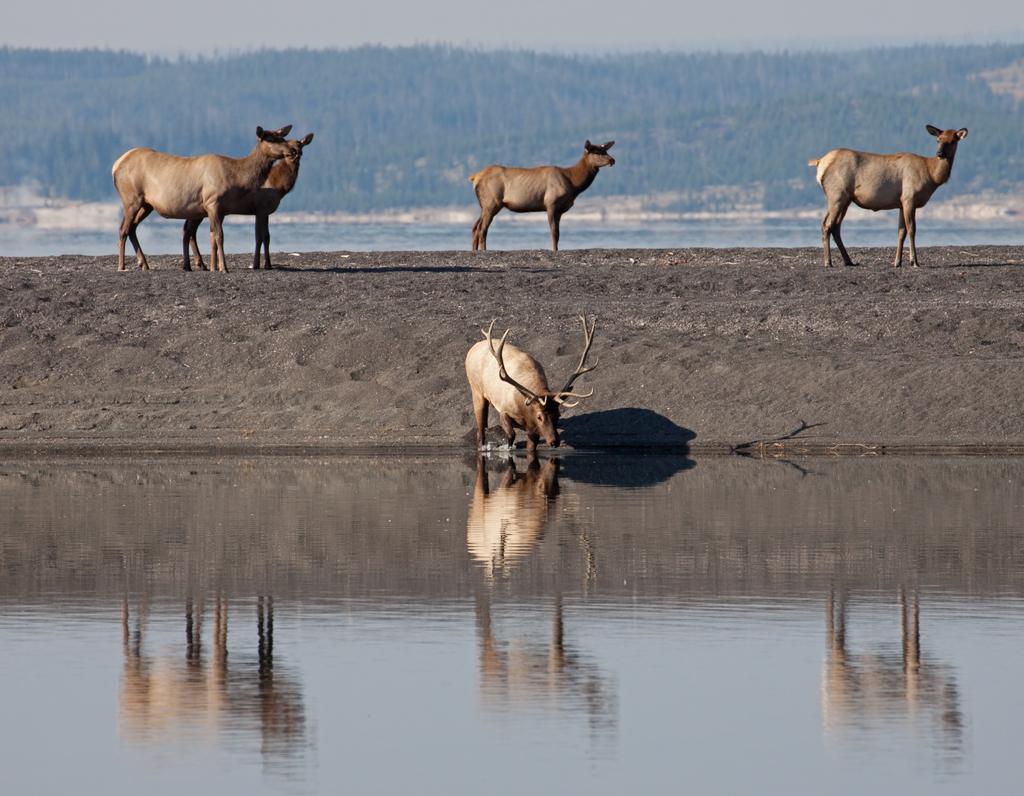Can you describe this image briefly? There is water at the bottom side of the image and a deer drinking water, there are animals, it seems like water, trees on the slope ground and the sky in the background area. 